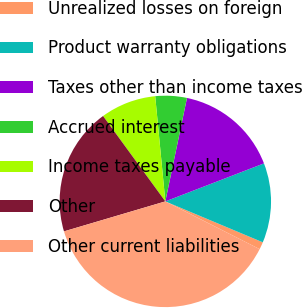Convert chart. <chart><loc_0><loc_0><loc_500><loc_500><pie_chart><fcel>Unrealized losses on foreign<fcel>Product warranty obligations<fcel>Taxes other than income taxes<fcel>Accrued interest<fcel>Income taxes payable<fcel>Other<fcel>Other current liabilities<nl><fcel>1.13%<fcel>12.18%<fcel>15.86%<fcel>4.81%<fcel>8.5%<fcel>19.55%<fcel>37.97%<nl></chart> 